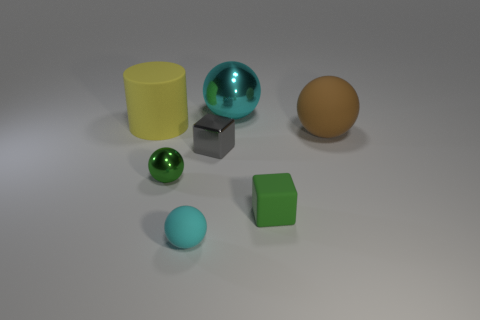Which objects in the image look like they could move easily if pushed? The spherical objects, which appear to be the green and blue balls, along with the shiny teal sphere, look like they'd roll away easily if pushed due to their shape and smooth surface. The yellow cylinder might also roll but not as smoothly. The cube, however, would likely slide rather than roll because of its shape. 